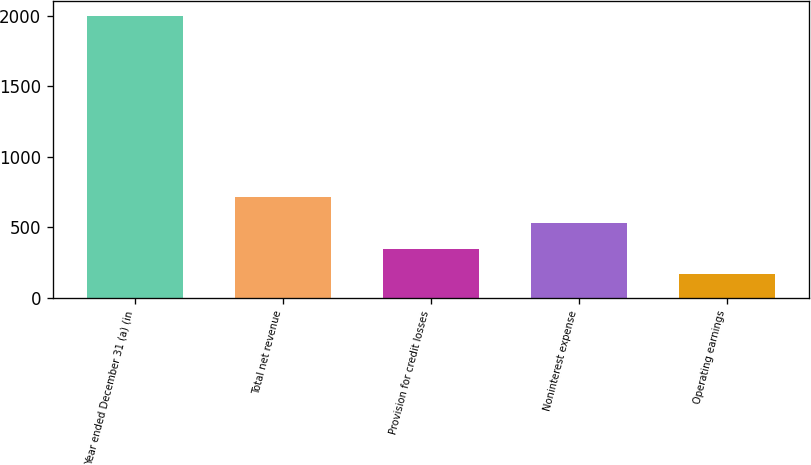<chart> <loc_0><loc_0><loc_500><loc_500><bar_chart><fcel>Year ended December 31 (a) (in<fcel>Total net revenue<fcel>Provision for credit losses<fcel>Noninterest expense<fcel>Operating earnings<nl><fcel>2002<fcel>716.8<fcel>349.6<fcel>533.2<fcel>166<nl></chart> 